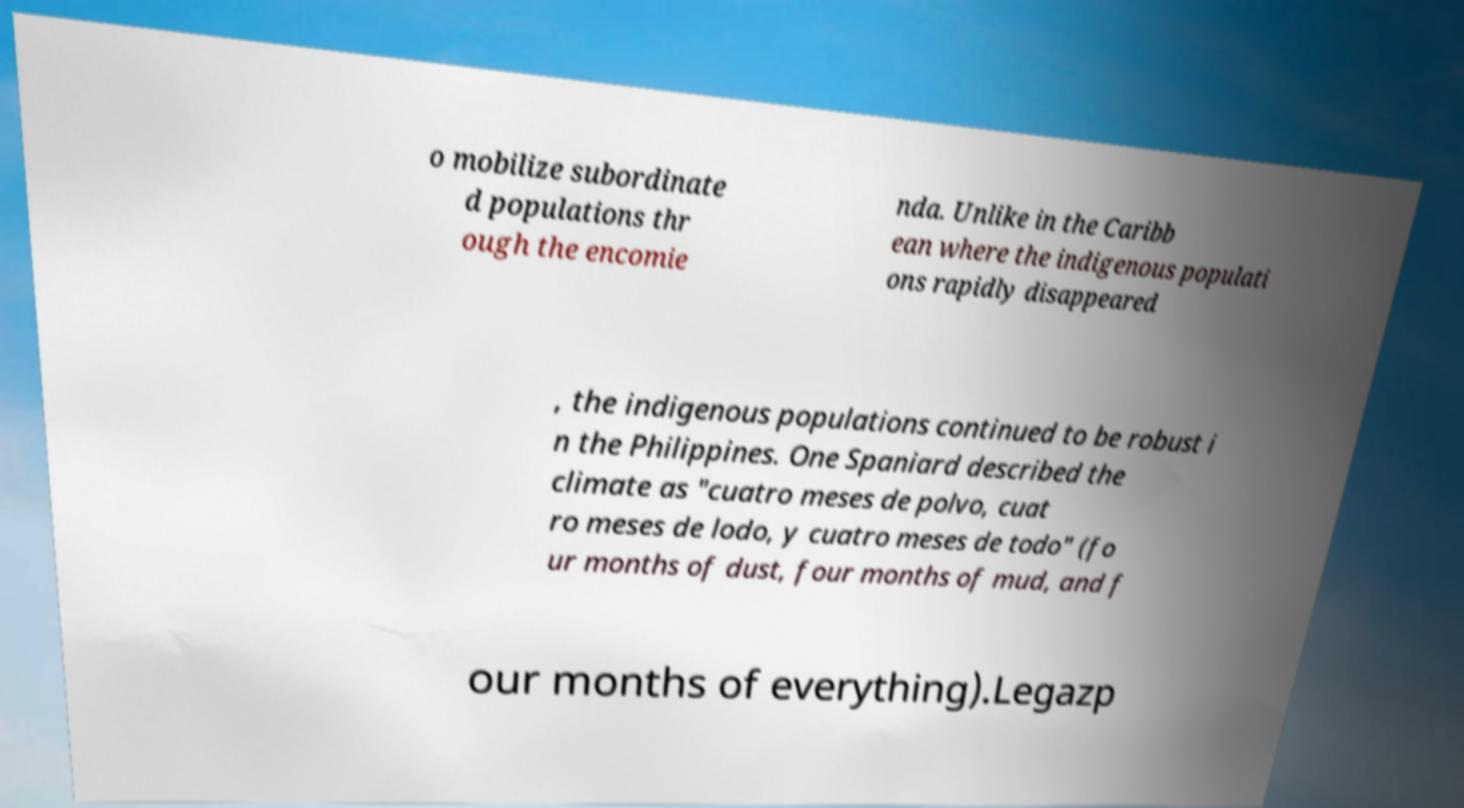For documentation purposes, I need the text within this image transcribed. Could you provide that? o mobilize subordinate d populations thr ough the encomie nda. Unlike in the Caribb ean where the indigenous populati ons rapidly disappeared , the indigenous populations continued to be robust i n the Philippines. One Spaniard described the climate as "cuatro meses de polvo, cuat ro meses de lodo, y cuatro meses de todo" (fo ur months of dust, four months of mud, and f our months of everything).Legazp 